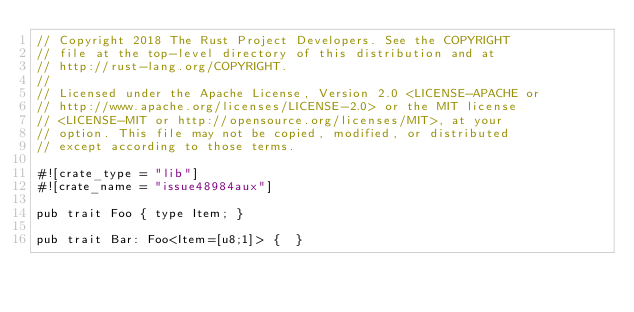Convert code to text. <code><loc_0><loc_0><loc_500><loc_500><_Rust_>// Copyright 2018 The Rust Project Developers. See the COPYRIGHT
// file at the top-level directory of this distribution and at
// http://rust-lang.org/COPYRIGHT.
//
// Licensed under the Apache License, Version 2.0 <LICENSE-APACHE or
// http://www.apache.org/licenses/LICENSE-2.0> or the MIT license
// <LICENSE-MIT or http://opensource.org/licenses/MIT>, at your
// option. This file may not be copied, modified, or distributed
// except according to those terms.

#![crate_type = "lib"]
#![crate_name = "issue48984aux"]

pub trait Foo { type Item; }

pub trait Bar: Foo<Item=[u8;1]> {  }
</code> 